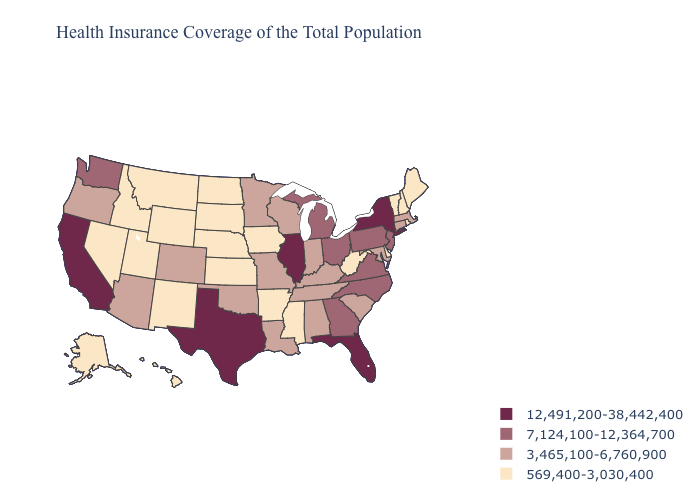Is the legend a continuous bar?
Answer briefly. No. Among the states that border Utah , which have the lowest value?
Concise answer only. Idaho, Nevada, New Mexico, Wyoming. Does the first symbol in the legend represent the smallest category?
Write a very short answer. No. What is the highest value in states that border Connecticut?
Keep it brief. 12,491,200-38,442,400. Which states have the lowest value in the West?
Be succinct. Alaska, Hawaii, Idaho, Montana, Nevada, New Mexico, Utah, Wyoming. Among the states that border Kansas , does Colorado have the lowest value?
Short answer required. No. What is the highest value in states that border Connecticut?
Short answer required. 12,491,200-38,442,400. Does Vermont have a higher value than Georgia?
Answer briefly. No. What is the value of Minnesota?
Quick response, please. 3,465,100-6,760,900. Does West Virginia have a lower value than Maine?
Short answer required. No. Is the legend a continuous bar?
Write a very short answer. No. What is the value of Virginia?
Quick response, please. 7,124,100-12,364,700. Name the states that have a value in the range 3,465,100-6,760,900?
Keep it brief. Alabama, Arizona, Colorado, Connecticut, Indiana, Kentucky, Louisiana, Maryland, Massachusetts, Minnesota, Missouri, Oklahoma, Oregon, South Carolina, Tennessee, Wisconsin. What is the value of New Jersey?
Quick response, please. 7,124,100-12,364,700. What is the value of Oklahoma?
Short answer required. 3,465,100-6,760,900. 